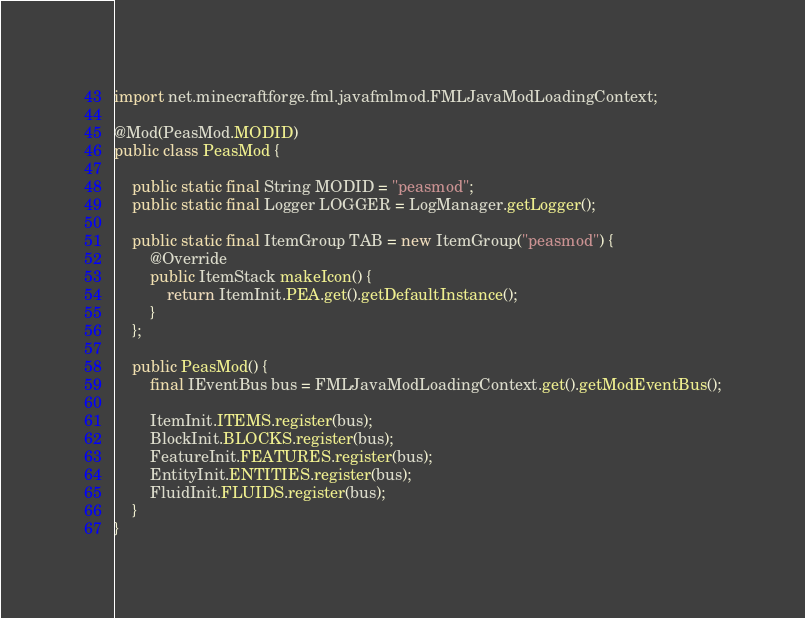Convert code to text. <code><loc_0><loc_0><loc_500><loc_500><_Java_>import net.minecraftforge.fml.javafmlmod.FMLJavaModLoadingContext;

@Mod(PeasMod.MODID)
public class PeasMod {

    public static final String MODID = "peasmod";
    public static final Logger LOGGER = LogManager.getLogger();

    public static final ItemGroup TAB = new ItemGroup("peasmod") {
        @Override
        public ItemStack makeIcon() {
            return ItemInit.PEA.get().getDefaultInstance();
        }
    };

    public PeasMod() {
        final IEventBus bus = FMLJavaModLoadingContext.get().getModEventBus();

        ItemInit.ITEMS.register(bus);
        BlockInit.BLOCKS.register(bus);
        FeatureInit.FEATURES.register(bus);
        EntityInit.ENTITIES.register(bus);
        FluidInit.FLUIDS.register(bus);
    }
}
</code> 